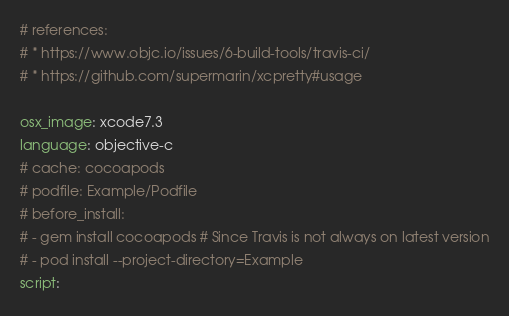<code> <loc_0><loc_0><loc_500><loc_500><_YAML_># references:
# * https://www.objc.io/issues/6-build-tools/travis-ci/
# * https://github.com/supermarin/xcpretty#usage

osx_image: xcode7.3
language: objective-c
# cache: cocoapods
# podfile: Example/Podfile
# before_install:
# - gem install cocoapods # Since Travis is not always on latest version
# - pod install --project-directory=Example
script:</code> 